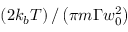<formula> <loc_0><loc_0><loc_500><loc_500>\left ( 2 k _ { b } T \right ) / \left ( \pi m \Gamma w _ { 0 } ^ { 2 } \right )</formula> 